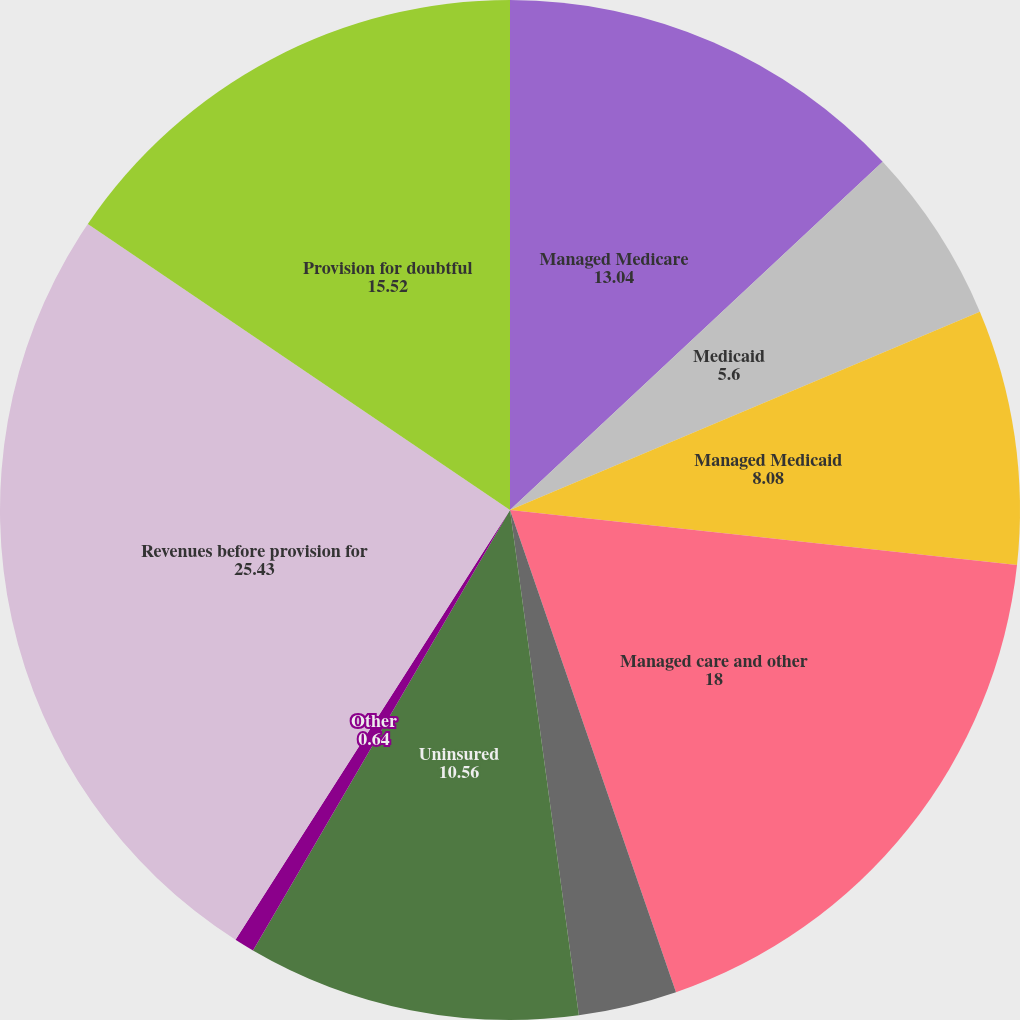Convert chart to OTSL. <chart><loc_0><loc_0><loc_500><loc_500><pie_chart><fcel>Managed Medicare<fcel>Medicaid<fcel>Managed Medicaid<fcel>Managed care and other<fcel>International (managed care<fcel>Uninsured<fcel>Other<fcel>Revenues before provision for<fcel>Provision for doubtful<nl><fcel>13.04%<fcel>5.6%<fcel>8.08%<fcel>18.0%<fcel>3.12%<fcel>10.56%<fcel>0.64%<fcel>25.43%<fcel>15.52%<nl></chart> 